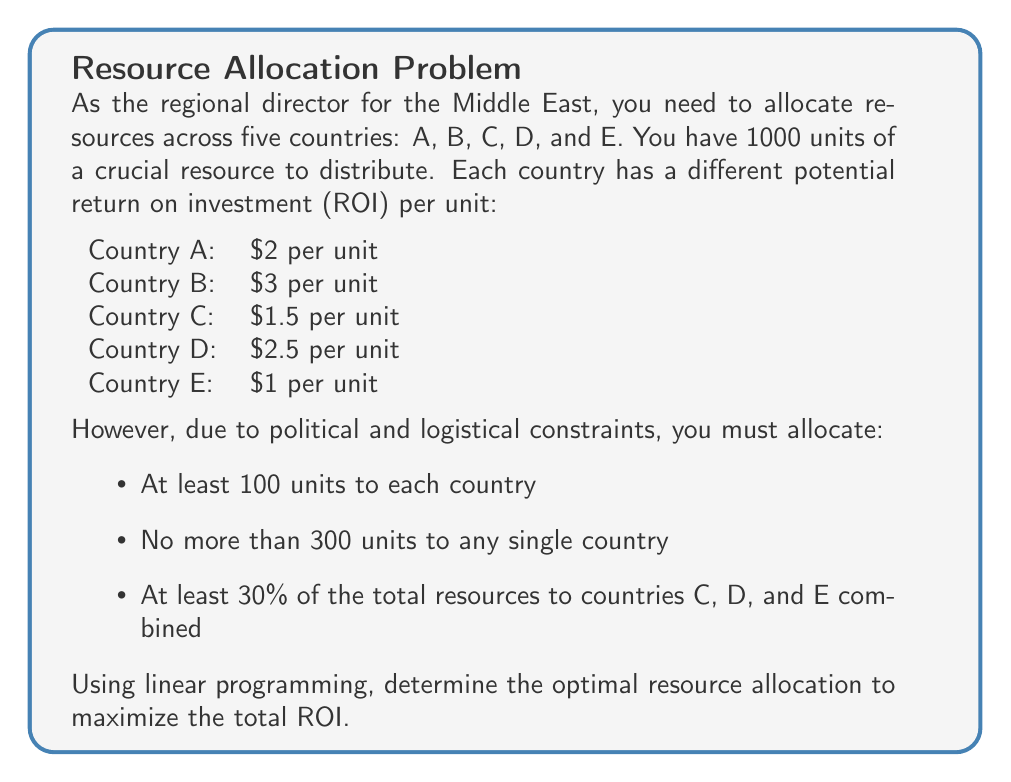Give your solution to this math problem. To solve this problem using linear programming, we need to:

1. Define variables:
Let $x_A, x_B, x_C, x_D, x_E$ represent the units allocated to each country.

2. Set up the objective function:
Maximize $Z = 2x_A + 3x_B + 1.5x_C + 2.5x_D + x_E$

3. Define constraints:
a) Total resources: $x_A + x_B + x_C + x_D + x_E = 1000$
b) Minimum allocation: $x_A, x_B, x_C, x_D, x_E \geq 100$
c) Maximum allocation: $x_A, x_B, x_C, x_D, x_E \leq 300$
d) Combined allocation for C, D, E: $x_C + x_D + x_E \geq 0.3(1000) = 300$

4. Solve using the simplex method or linear programming software.

The optimal solution is:
$x_A = 300$
$x_B = 300$
$x_C = 100$
$x_D = 200$
$x_E = 100$

5. Calculate the maximum ROI:
$Z = 2(300) + 3(300) + 1.5(100) + 2.5(200) + 1(100) = 2450$

This allocation satisfies all constraints:
- Total resources used: 300 + 300 + 100 + 200 + 100 = 1000 units
- Each country receives at least 100 units
- No country receives more than 300 units
- Countries C, D, and E combined receive 400 units, which is more than 30% of the total

The optimal allocation maximizes the ROI by allocating the maximum allowed resources to the countries with the highest ROI (A and B), while meeting the minimum requirements for the other countries.
Answer: Optimal allocation: A: 300, B: 300, C: 100, D: 200, E: 100. Maximum ROI: $2450. 